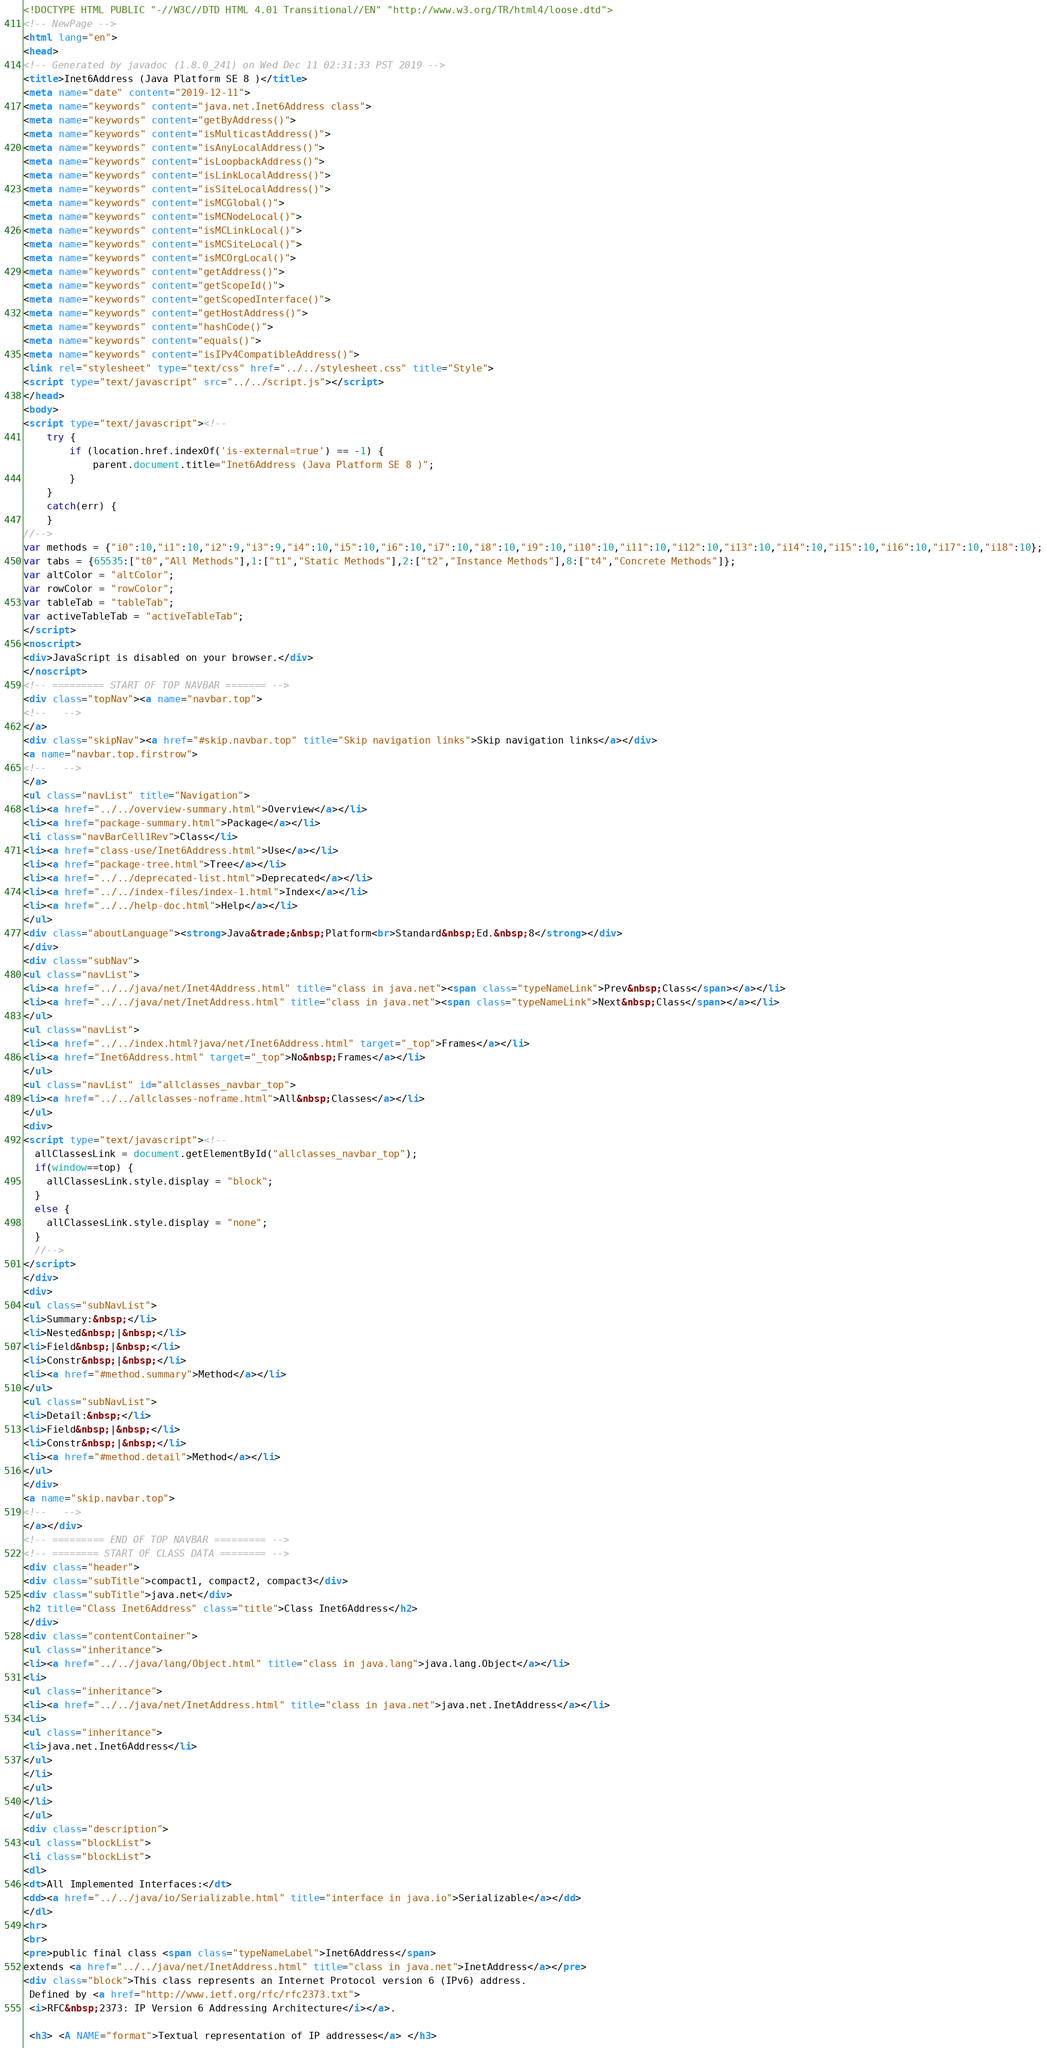<code> <loc_0><loc_0><loc_500><loc_500><_HTML_><!DOCTYPE HTML PUBLIC "-//W3C//DTD HTML 4.01 Transitional//EN" "http://www.w3.org/TR/html4/loose.dtd">
<!-- NewPage -->
<html lang="en">
<head>
<!-- Generated by javadoc (1.8.0_241) on Wed Dec 11 02:31:33 PST 2019 -->
<title>Inet6Address (Java Platform SE 8 )</title>
<meta name="date" content="2019-12-11">
<meta name="keywords" content="java.net.Inet6Address class">
<meta name="keywords" content="getByAddress()">
<meta name="keywords" content="isMulticastAddress()">
<meta name="keywords" content="isAnyLocalAddress()">
<meta name="keywords" content="isLoopbackAddress()">
<meta name="keywords" content="isLinkLocalAddress()">
<meta name="keywords" content="isSiteLocalAddress()">
<meta name="keywords" content="isMCGlobal()">
<meta name="keywords" content="isMCNodeLocal()">
<meta name="keywords" content="isMCLinkLocal()">
<meta name="keywords" content="isMCSiteLocal()">
<meta name="keywords" content="isMCOrgLocal()">
<meta name="keywords" content="getAddress()">
<meta name="keywords" content="getScopeId()">
<meta name="keywords" content="getScopedInterface()">
<meta name="keywords" content="getHostAddress()">
<meta name="keywords" content="hashCode()">
<meta name="keywords" content="equals()">
<meta name="keywords" content="isIPv4CompatibleAddress()">
<link rel="stylesheet" type="text/css" href="../../stylesheet.css" title="Style">
<script type="text/javascript" src="../../script.js"></script>
</head>
<body>
<script type="text/javascript"><!--
    try {
        if (location.href.indexOf('is-external=true') == -1) {
            parent.document.title="Inet6Address (Java Platform SE 8 )";
        }
    }
    catch(err) {
    }
//-->
var methods = {"i0":10,"i1":10,"i2":9,"i3":9,"i4":10,"i5":10,"i6":10,"i7":10,"i8":10,"i9":10,"i10":10,"i11":10,"i12":10,"i13":10,"i14":10,"i15":10,"i16":10,"i17":10,"i18":10};
var tabs = {65535:["t0","All Methods"],1:["t1","Static Methods"],2:["t2","Instance Methods"],8:["t4","Concrete Methods"]};
var altColor = "altColor";
var rowColor = "rowColor";
var tableTab = "tableTab";
var activeTableTab = "activeTableTab";
</script>
<noscript>
<div>JavaScript is disabled on your browser.</div>
</noscript>
<!-- ========= START OF TOP NAVBAR ======= -->
<div class="topNav"><a name="navbar.top">
<!--   -->
</a>
<div class="skipNav"><a href="#skip.navbar.top" title="Skip navigation links">Skip navigation links</a></div>
<a name="navbar.top.firstrow">
<!--   -->
</a>
<ul class="navList" title="Navigation">
<li><a href="../../overview-summary.html">Overview</a></li>
<li><a href="package-summary.html">Package</a></li>
<li class="navBarCell1Rev">Class</li>
<li><a href="class-use/Inet6Address.html">Use</a></li>
<li><a href="package-tree.html">Tree</a></li>
<li><a href="../../deprecated-list.html">Deprecated</a></li>
<li><a href="../../index-files/index-1.html">Index</a></li>
<li><a href="../../help-doc.html">Help</a></li>
</ul>
<div class="aboutLanguage"><strong>Java&trade;&nbsp;Platform<br>Standard&nbsp;Ed.&nbsp;8</strong></div>
</div>
<div class="subNav">
<ul class="navList">
<li><a href="../../java/net/Inet4Address.html" title="class in java.net"><span class="typeNameLink">Prev&nbsp;Class</span></a></li>
<li><a href="../../java/net/InetAddress.html" title="class in java.net"><span class="typeNameLink">Next&nbsp;Class</span></a></li>
</ul>
<ul class="navList">
<li><a href="../../index.html?java/net/Inet6Address.html" target="_top">Frames</a></li>
<li><a href="Inet6Address.html" target="_top">No&nbsp;Frames</a></li>
</ul>
<ul class="navList" id="allclasses_navbar_top">
<li><a href="../../allclasses-noframe.html">All&nbsp;Classes</a></li>
</ul>
<div>
<script type="text/javascript"><!--
  allClassesLink = document.getElementById("allclasses_navbar_top");
  if(window==top) {
    allClassesLink.style.display = "block";
  }
  else {
    allClassesLink.style.display = "none";
  }
  //-->
</script>
</div>
<div>
<ul class="subNavList">
<li>Summary:&nbsp;</li>
<li>Nested&nbsp;|&nbsp;</li>
<li>Field&nbsp;|&nbsp;</li>
<li>Constr&nbsp;|&nbsp;</li>
<li><a href="#method.summary">Method</a></li>
</ul>
<ul class="subNavList">
<li>Detail:&nbsp;</li>
<li>Field&nbsp;|&nbsp;</li>
<li>Constr&nbsp;|&nbsp;</li>
<li><a href="#method.detail">Method</a></li>
</ul>
</div>
<a name="skip.navbar.top">
<!--   -->
</a></div>
<!-- ========= END OF TOP NAVBAR ========= -->
<!-- ======== START OF CLASS DATA ======== -->
<div class="header">
<div class="subTitle">compact1, compact2, compact3</div>
<div class="subTitle">java.net</div>
<h2 title="Class Inet6Address" class="title">Class Inet6Address</h2>
</div>
<div class="contentContainer">
<ul class="inheritance">
<li><a href="../../java/lang/Object.html" title="class in java.lang">java.lang.Object</a></li>
<li>
<ul class="inheritance">
<li><a href="../../java/net/InetAddress.html" title="class in java.net">java.net.InetAddress</a></li>
<li>
<ul class="inheritance">
<li>java.net.Inet6Address</li>
</ul>
</li>
</ul>
</li>
</ul>
<div class="description">
<ul class="blockList">
<li class="blockList">
<dl>
<dt>All Implemented Interfaces:</dt>
<dd><a href="../../java/io/Serializable.html" title="interface in java.io">Serializable</a></dd>
</dl>
<hr>
<br>
<pre>public final class <span class="typeNameLabel">Inet6Address</span>
extends <a href="../../java/net/InetAddress.html" title="class in java.net">InetAddress</a></pre>
<div class="block">This class represents an Internet Protocol version 6 (IPv6) address.
 Defined by <a href="http://www.ietf.org/rfc/rfc2373.txt">
 <i>RFC&nbsp;2373: IP Version 6 Addressing Architecture</i></a>.

 <h3> <A NAME="format">Textual representation of IP addresses</a> </h3>
</code> 